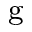Convert formula to latex. <formula><loc_0><loc_0><loc_500><loc_500>^ { g }</formula> 